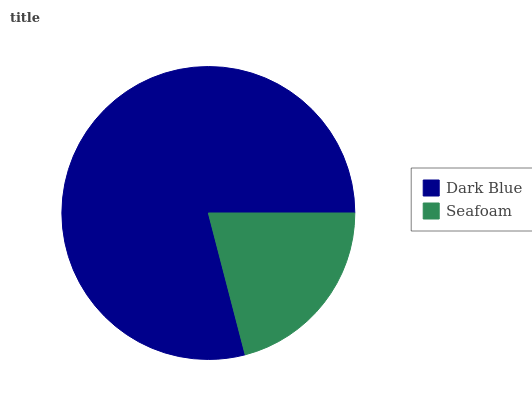Is Seafoam the minimum?
Answer yes or no. Yes. Is Dark Blue the maximum?
Answer yes or no. Yes. Is Seafoam the maximum?
Answer yes or no. No. Is Dark Blue greater than Seafoam?
Answer yes or no. Yes. Is Seafoam less than Dark Blue?
Answer yes or no. Yes. Is Seafoam greater than Dark Blue?
Answer yes or no. No. Is Dark Blue less than Seafoam?
Answer yes or no. No. Is Dark Blue the high median?
Answer yes or no. Yes. Is Seafoam the low median?
Answer yes or no. Yes. Is Seafoam the high median?
Answer yes or no. No. Is Dark Blue the low median?
Answer yes or no. No. 